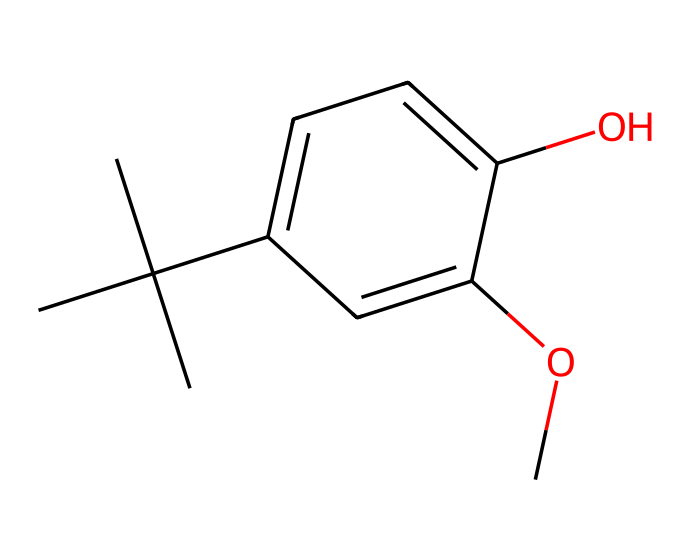What is the molecular formula of butylated hydroxyanisole? To determine the molecular formula, count the different types of atoms in the structure based on the SMILES. The structure contains 11 carbon atoms (C), 16 hydrogen atoms (H), and 3 oxygen atoms (O). Thus, combining these gives the molecular formula C11H16O3.
Answer: C11H16O3 How many rings are present in this molecule? Examining the structure in the SMILES representation, there is only one aromatic ring present in butylated hydroxyanisole, indicated by 'c1ccc', which represents a cyclic structure.
Answer: 1 What functional groups are identified in butylated hydroxyanisole? Looking at the structure, there are two distinct functional groups: a hydroxyl group (-OH) and an ether group (characterized by the -O- linkage to a methyl group -O-CH3). These are identifiable from the -OH and -O- groups in the structure.
Answer: hydroxyl and ether Is butylated hydroxyanisole a polar or non-polar compound? By analyzing the functional groups and the overall structure, hydroxyl groups are polar, contributing to the polarity of the molecule. However, the larger hydrocarbon part makes it generally more non-polar. Thus, it possesses both traits, but its non-polar characteristics are more significant.
Answer: non-polar What is the primary role of butylated hydroxyanisole in maritime fuel preservation? Butylated hydroxyanisole acts as an antioxidant to prevent the oxidation of ship fuel, which helps in extending the fuel's shelf life and maintaining its quality during storage.
Answer: antioxidant How does the presence of butylated hydroxyanisole affect the stability of ship fuel? As an antioxidant, butylated hydroxyanisole effectively inhibits the oxidation reactions that can lead to fuel degradation, thus enhancing the overall stability and performance of the ship's fuel.
Answer: enhances stability 